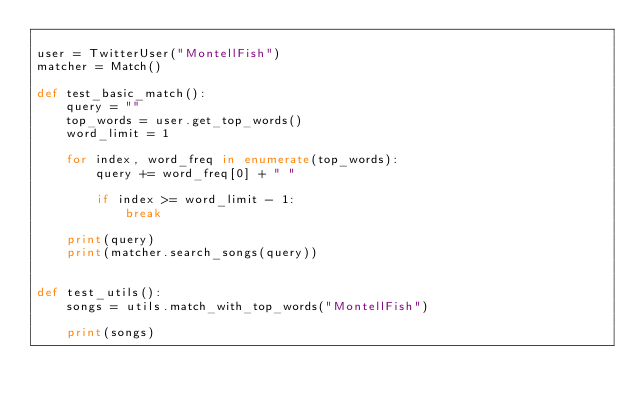Convert code to text. <code><loc_0><loc_0><loc_500><loc_500><_Python_>
user = TwitterUser("MontellFish")
matcher = Match()

def test_basic_match():
    query = ""
    top_words = user.get_top_words()
    word_limit = 1

    for index, word_freq in enumerate(top_words):
        query += word_freq[0] + " "

        if index >= word_limit - 1:
            break

    print(query)
    print(matcher.search_songs(query))


def test_utils():
    songs = utils.match_with_top_words("MontellFish")

    print(songs)
</code> 